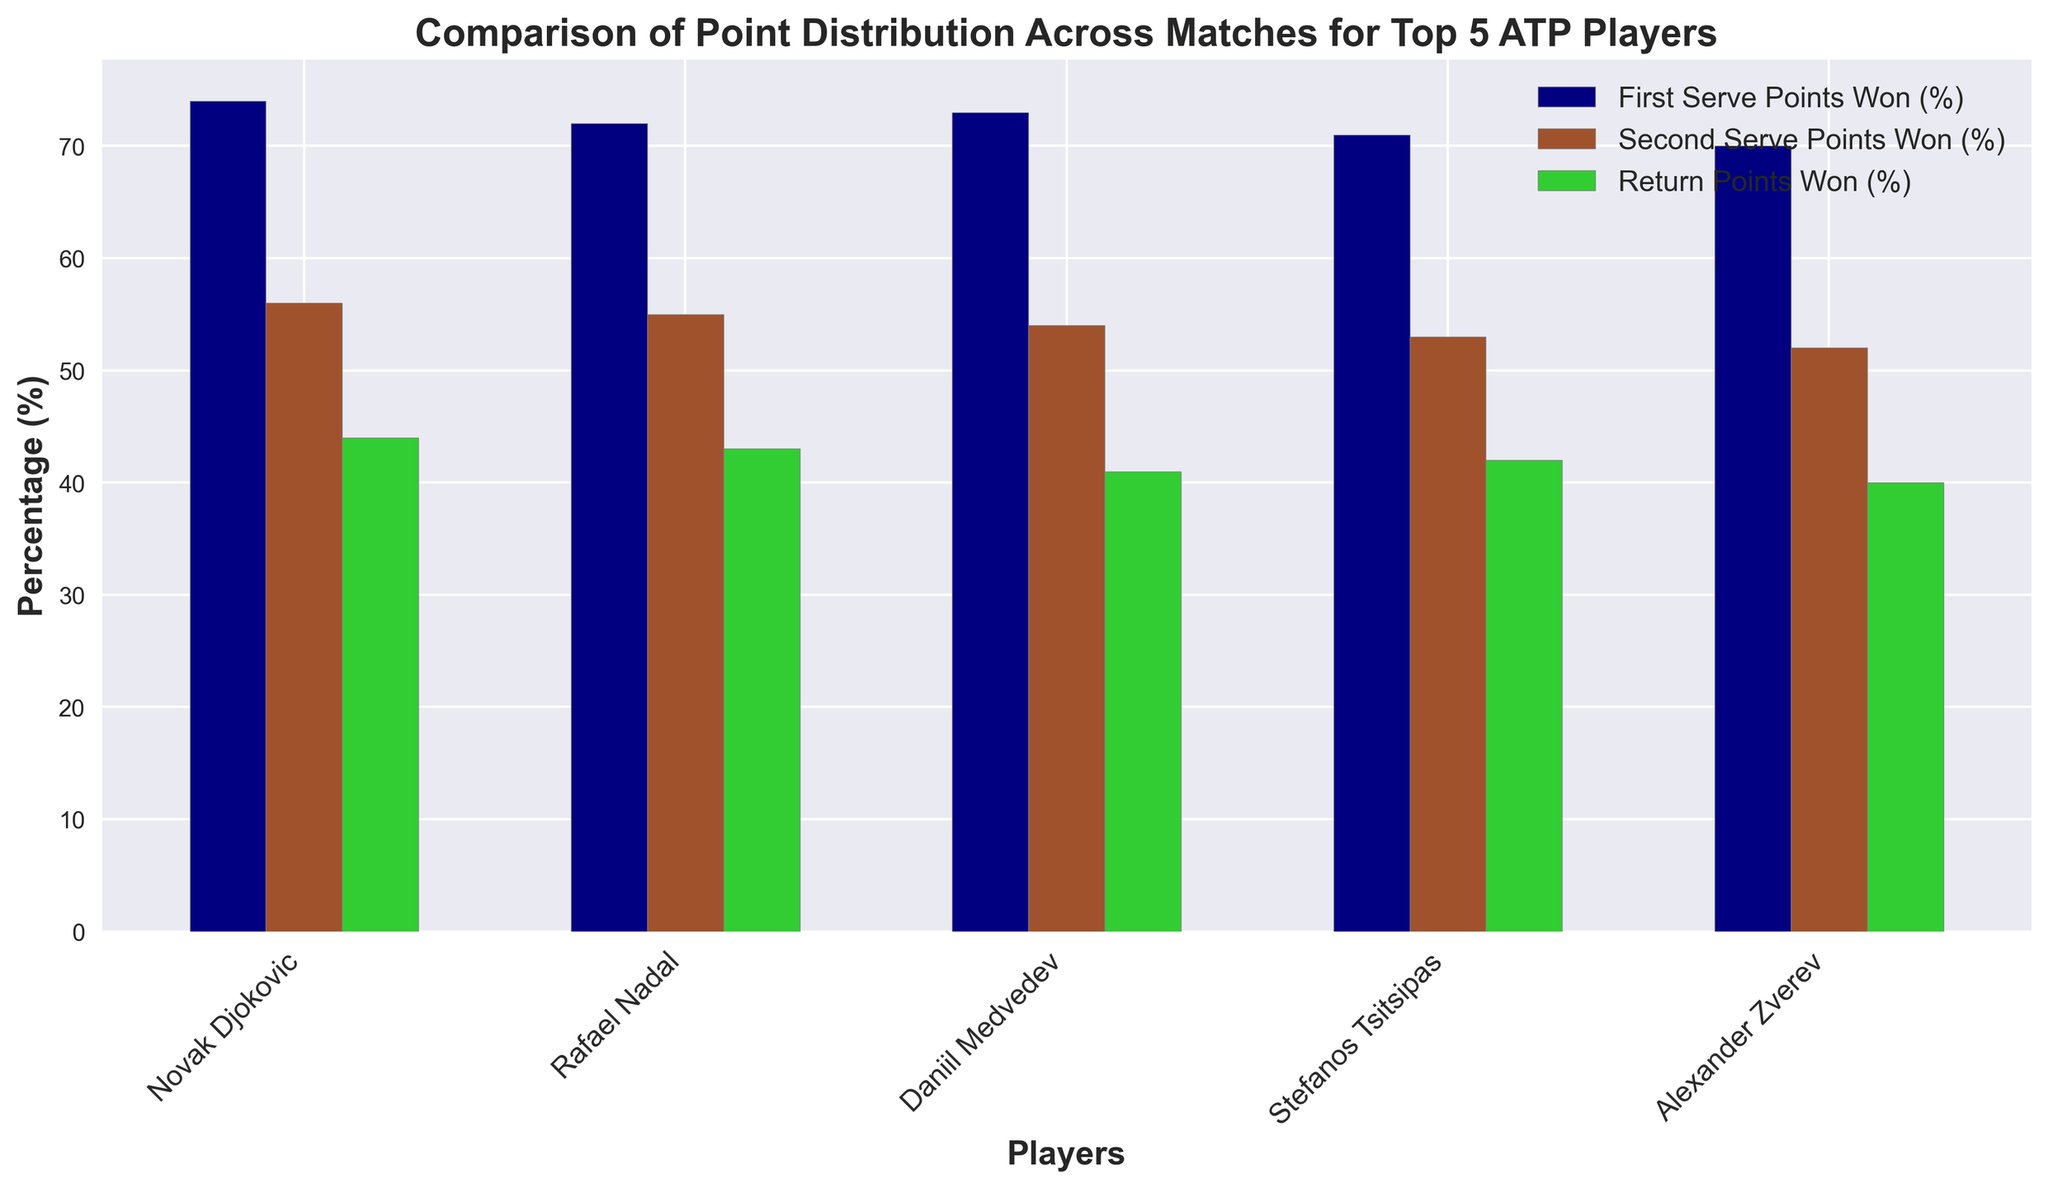Which player has the highest percentage of First Serve Points Won (%)? Look at the bars representing "First Serve Points Won (%)" for each player. Novak Djokovic has the tallest bar in this category, representing 74%.
Answer: Novak Djokovic How does the percentage of Return Points Won (%) for Daniil Medvedev compare to that for Rafael Nadal? Compare the "Return Points Won (%)" bars for Daniil Medvedev and Rafael Nadal. Daniil Medvedev's bar is lower than Rafael Nadal's, showing 41% compared to 43%.
Answer: Daniil Medvedev has a lower percentage than Rafael Nadal Which player has the smallest difference between their First Serve Points Won (%) and Second Serve Points Won (%)? Calculate the difference between "First Serve Points Won (%)" and "Second Serve Points Won (%)" for each player. 
- Novak Djokovic: 74 - 56 = 18 
- Rafael Nadal: 72 - 55 = 17
- Daniil Medvedev: 73 - 54 = 19
- Stefanos Tsitsipas: 71 - 53 = 18
- Alexander Zverev: 70 - 52 = 18
Rafael Nadal has the smallest difference of 17.
Answer: Rafael Nadal What is the combined percentage of Return Points Won (%) for all players? Sum the "Return Points Won (%)" values for all players:
44 (Djokovic) + 43 (Nadal) + 41 (Medvedev) + 42 (Tsitsipas) + 40 (Zverev) = 210.
Answer: 210 Compare the average percentage of First Serve Points Won (%) with Second Serve Points Won (%). Which is higher? Calculate the averages:
First Serve Points Won: (74 + 72 + 73 + 71 + 70) / 5 = 72%
Second Serve Points Won: (56 + 55 + 54 + 53 + 52) / 5 = 54%
The average for First Serve Points Won (%) is higher.
Answer: First Serve Points Won (%) is higher Which categories do Novak Djokovic and Rafael Nadal have the same ranking in terms of percentage? Compare the rankings of percentages in each category:
- First Serve Points Won (%): Djokovic is first, Nadal is second 
- Second Serve Points Won (%): Djokovic is first, Nadal is second
- Return Points Won (%): Djokovic is first, Nadal is second
They have the same ranking in all categories.
Answer: All categories What is the difference between the highest and lowest percentages of Return Points Won (%) among the players? Identify the highest and lowest percentages in the "Return Points Won (%)" category:
Highest: 44% (Novak Djokovic)
Lowest: 40% (Alexander Zverev)
Difference: 44 - 40 = 4%.
Answer: 4% Who has a closer percentage of First Serve Points Won (%) and Second Serve Points Won (%), Stefanos Tsitsipas or Alexander Zverev? Calculate the difference between First and Second Serve Points Won for each player:
- Stefanos Tsitsipas: 71 - 53 = 18
- Alexander Zverev: 70 - 52 = 18
Both have the same difference.
Answer: Both have the same 